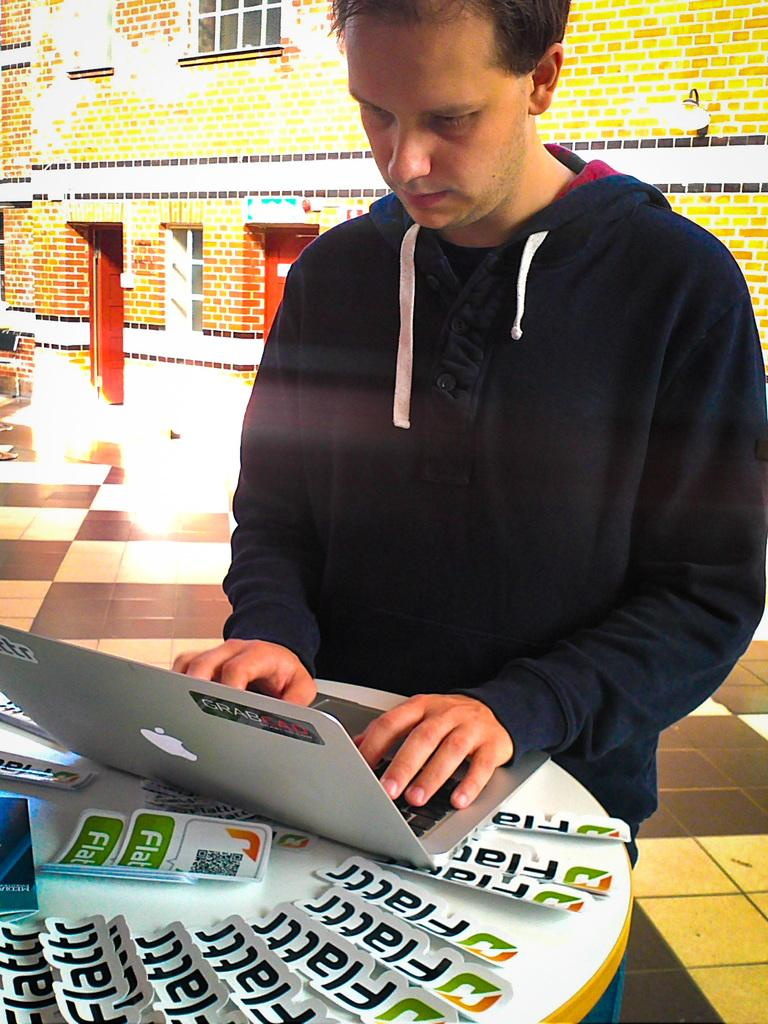What is the person in the image doing? There is a person operating a laptop in the image. What can be seen on the table in the image? There are stickers on the table in the image. What is visible in the background of the image? There is a building and a lamp in the background of the image. What type of sand can be seen on the station in the image? There is no station or sand present in the image. 